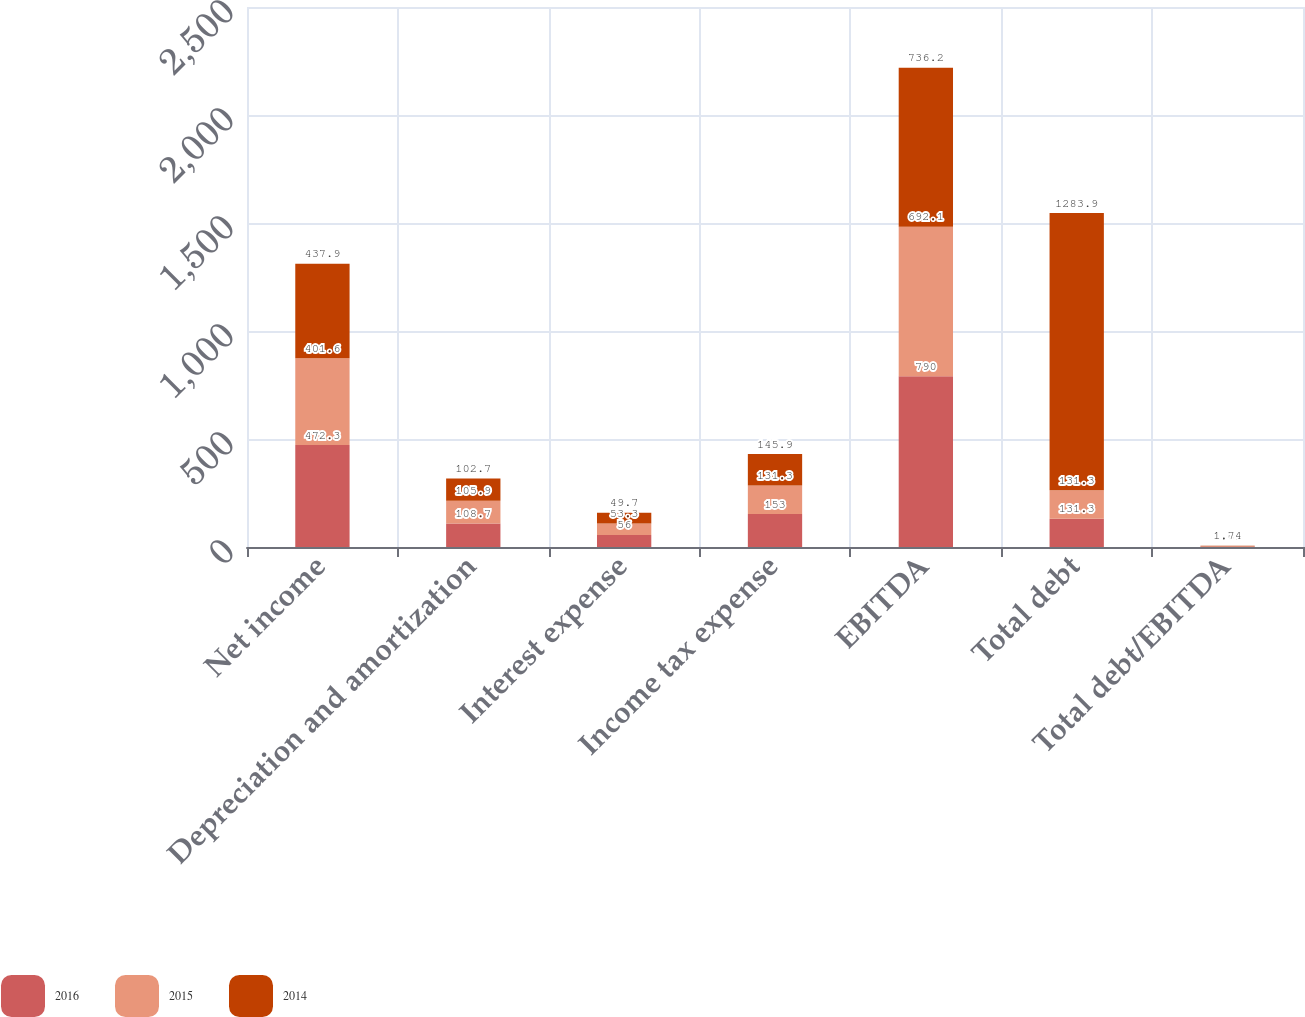Convert chart. <chart><loc_0><loc_0><loc_500><loc_500><stacked_bar_chart><ecel><fcel>Net income<fcel>Depreciation and amortization<fcel>Interest expense<fcel>Income tax expense<fcel>EBITDA<fcel>Total debt<fcel>Total debt/EBITDA<nl><fcel>2016<fcel>472.3<fcel>108.7<fcel>56<fcel>153<fcel>790<fcel>131.3<fcel>1.83<nl><fcel>2015<fcel>401.6<fcel>105.9<fcel>53.3<fcel>131.3<fcel>692.1<fcel>131.3<fcel>2.01<nl><fcel>2014<fcel>437.9<fcel>102.7<fcel>49.7<fcel>145.9<fcel>736.2<fcel>1283.9<fcel>1.74<nl></chart> 